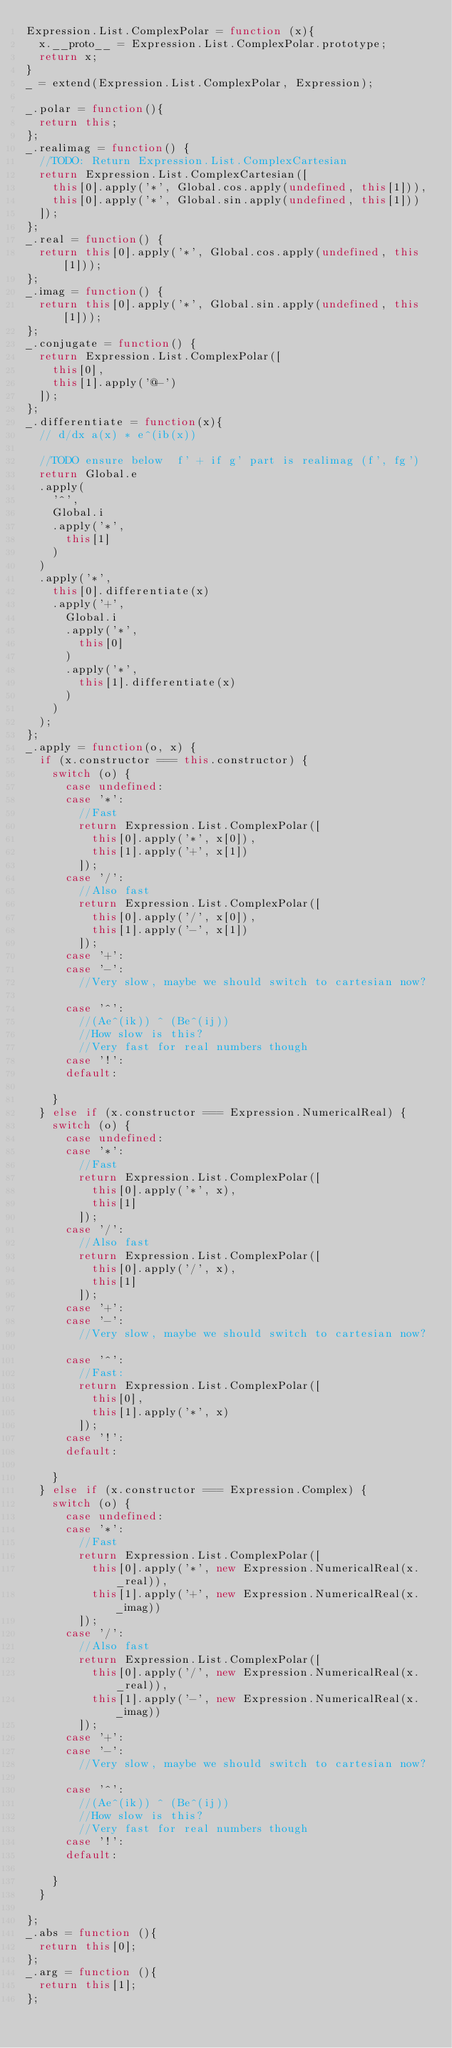Convert code to text. <code><loc_0><loc_0><loc_500><loc_500><_JavaScript_>Expression.List.ComplexPolar = function (x){
	x.__proto__ = Expression.List.ComplexPolar.prototype;
	return x;
}
_ = extend(Expression.List.ComplexPolar, Expression);

_.polar = function(){
	return this;
};
_.realimag = function() {
	//TODO: Return Expression.List.ComplexCartesian
	return Expression.List.ComplexCartesian([
		this[0].apply('*', Global.cos.apply(undefined, this[1])),
		this[0].apply('*', Global.sin.apply(undefined, this[1]))
	]);
};
_.real = function() {
	return this[0].apply('*', Global.cos.apply(undefined, this[1]));
};
_.imag = function() {
	return this[0].apply('*', Global.sin.apply(undefined, this[1]));
};
_.conjugate = function() {
	return Expression.List.ComplexPolar([
		this[0],
		this[1].apply('@-')
	]);
};
_.differentiate = function(x){
	// d/dx a(x) * e^(ib(x))
	
	//TODO ensure below  f' + if g' part is realimag (f', fg')
	return Global.e
	.apply(
		'^',
		Global.i
		.apply('*',
			this[1]
		)
	)
	.apply('*',
		this[0].differentiate(x)
		.apply('+',
			Global.i
			.apply('*',
				this[0]
			)
			.apply('*',
				this[1].differentiate(x)
			)
		)
	);
};
_.apply = function(o, x) {
	if (x.constructor === this.constructor) {
		switch (o) {
			case undefined:
			case '*':
				//Fast
				return Expression.List.ComplexPolar([
					this[0].apply('*', x[0]),
					this[1].apply('+', x[1])
				]);
			case '/':
				//Also fast
				return Expression.List.ComplexPolar([
					this[0].apply('/', x[0]),
					this[1].apply('-', x[1])
				]);
			case '+':
			case '-':
				//Very slow, maybe we should switch to cartesian now?
			
			case '^':
				//(Ae^(ik)) ^ (Be^(ij))
				//How slow is this?
				//Very fast for real numbers though
			case '!':
			default:
			
		}
	} else if (x.constructor === Expression.NumericalReal) {
		switch (o) {
			case undefined:
			case '*':
				//Fast
				return Expression.List.ComplexPolar([
					this[0].apply('*', x),
					this[1]
				]);
			case '/':
				//Also fast
				return Expression.List.ComplexPolar([
					this[0].apply('/', x),
					this[1]
				]);
			case '+':
			case '-':
				//Very slow, maybe we should switch to cartesian now?
			
			case '^':
				//Fast:
				return Expression.List.ComplexPolar([
					this[0],
					this[1].apply('*', x)
				]);
			case '!':
			default:
			
		}
	} else if (x.constructor === Expression.Complex) {
		switch (o) {
			case undefined:
			case '*':
				//Fast
				return Expression.List.ComplexPolar([
					this[0].apply('*', new Expression.NumericalReal(x._real)),
					this[1].apply('+', new Expression.NumericalReal(x._imag))
				]);
			case '/':
				//Also fast
				return Expression.List.ComplexPolar([
					this[0].apply('/', new Expression.NumericalReal(x._real)),
					this[1].apply('-', new Expression.NumericalReal(x._imag))
				]);
			case '+':
			case '-':
				//Very slow, maybe we should switch to cartesian now?
			
			case '^':
				//(Ae^(ik)) ^ (Be^(ij))
				//How slow is this?
				//Very fast for real numbers though
			case '!':
			default:
			
		}
	}
	
};
_.abs = function (){
	return this[0];
};
_.arg = function (){
	return this[1];
};</code> 